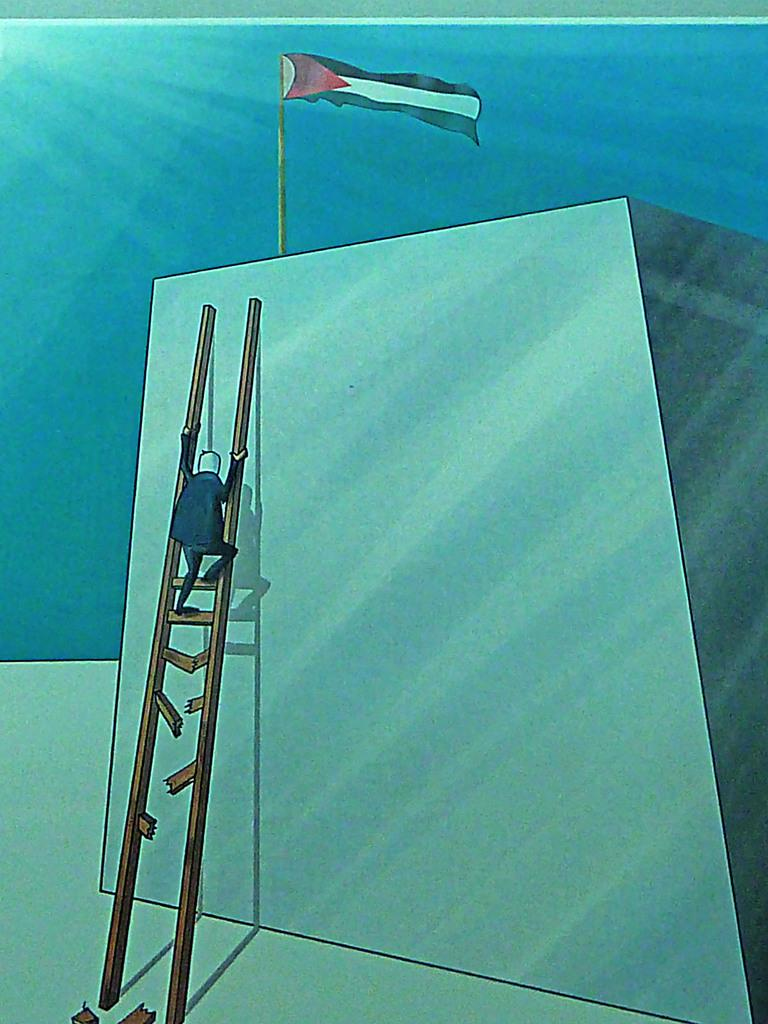What is the person in the image doing? The person is standing on a ladder. What is on top of the block in the image? There is a flag on top of the block. What can be seen in the background of the image? The background of the image includes the sky. What type of can is visible in the image? There is no can present in the image. How does the flag compare to the unit in the image? There is no unit present in the image for comparison with the flag. 